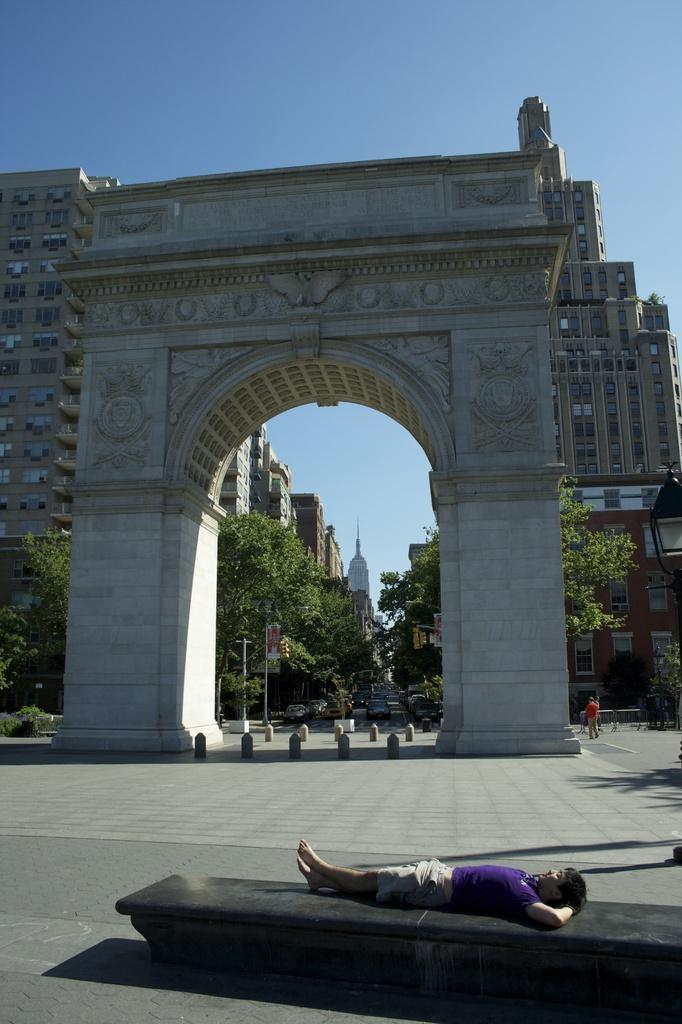Please provide a concise description of this image. At the bottom of the image we can see one person is lying on the bench. In the background, we can see the sky, clouds, one arch, buildings, poles, trees, fences, plants, windows, few vehicles on the road, one person is standing and a few other objects. 